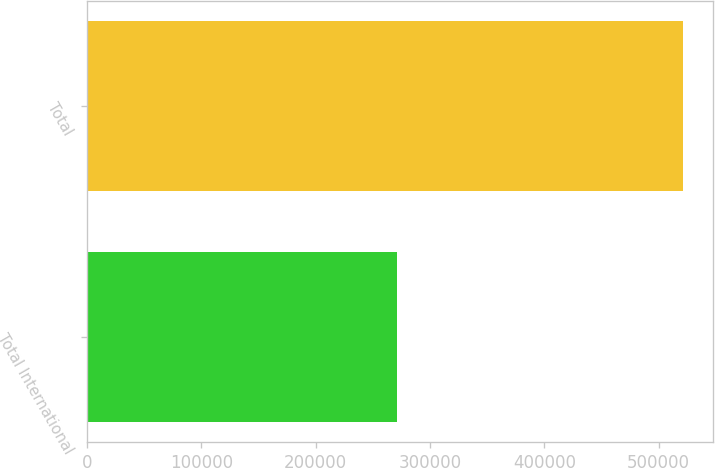Convert chart. <chart><loc_0><loc_0><loc_500><loc_500><bar_chart><fcel>Total International<fcel>Total<nl><fcel>271189<fcel>521552<nl></chart> 